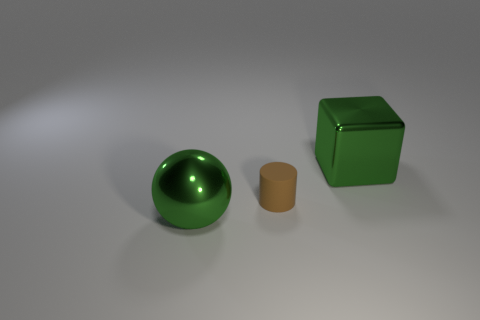Add 1 green metal balls. How many objects exist? 4 Subtract 1 spheres. How many spheres are left? 0 Subtract 0 red cylinders. How many objects are left? 3 Subtract all spheres. How many objects are left? 2 Subtract all purple cylinders. Subtract all green balls. How many cylinders are left? 1 Subtract all purple balls. How many cyan cylinders are left? 0 Subtract all green cubes. Subtract all green metal spheres. How many objects are left? 1 Add 3 green metal things. How many green metal things are left? 5 Add 3 green blocks. How many green blocks exist? 4 